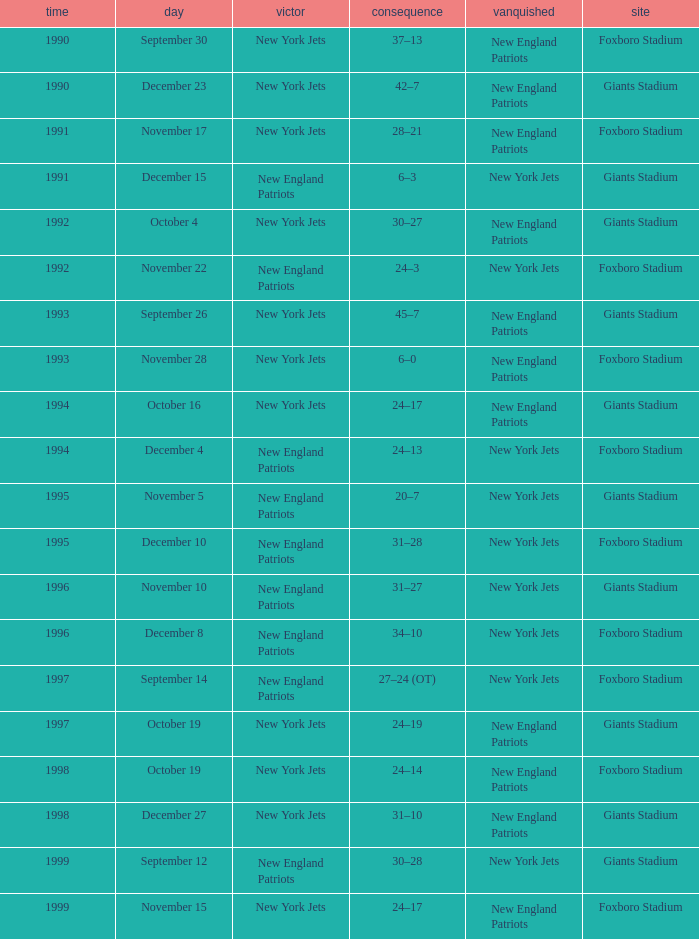What is the name of the Loser when the winner was new england patriots, and a Location of giants stadium, and a Result of 30–28? New York Jets. 